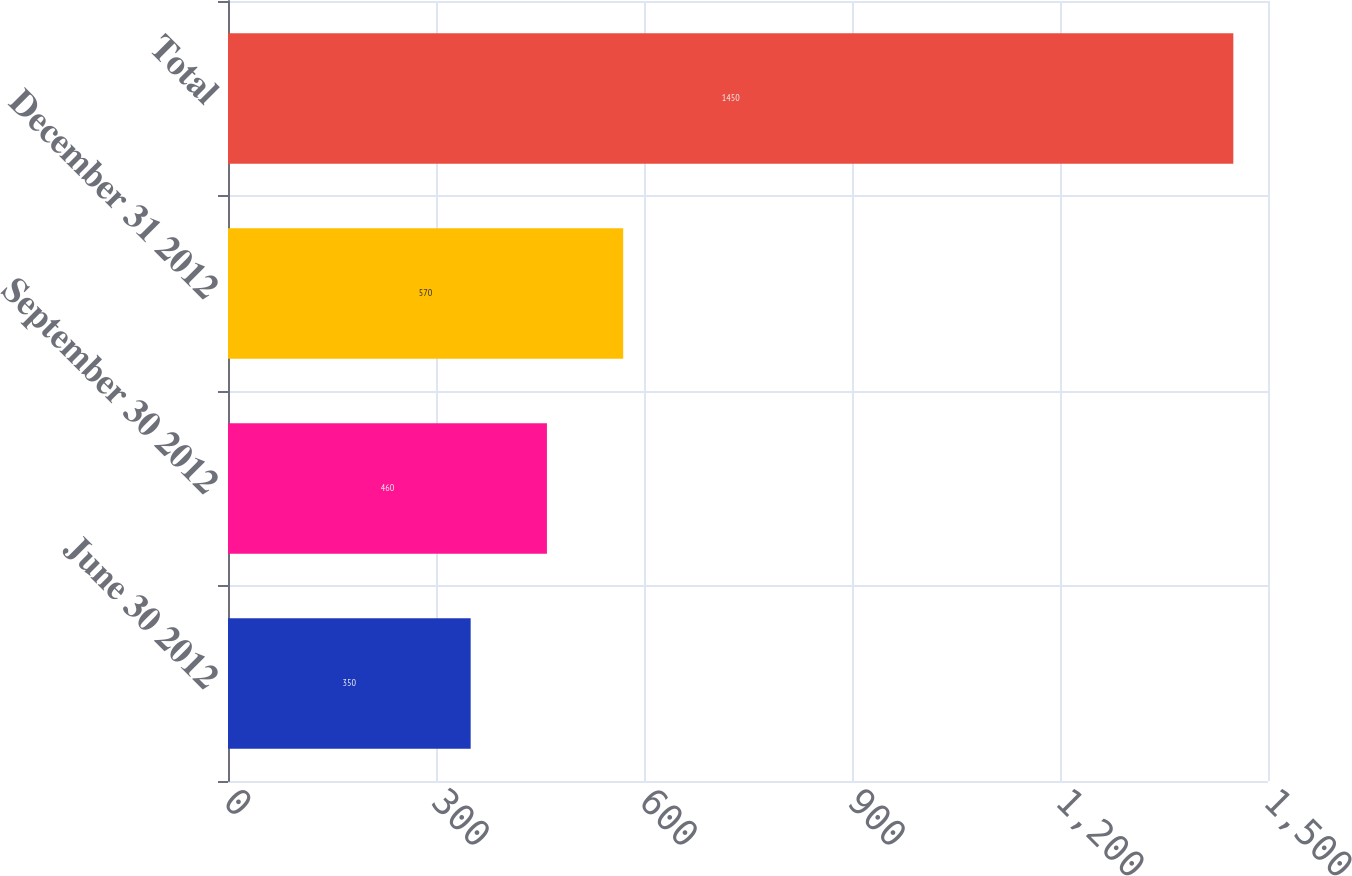<chart> <loc_0><loc_0><loc_500><loc_500><bar_chart><fcel>June 30 2012<fcel>September 30 2012<fcel>December 31 2012<fcel>Total<nl><fcel>350<fcel>460<fcel>570<fcel>1450<nl></chart> 